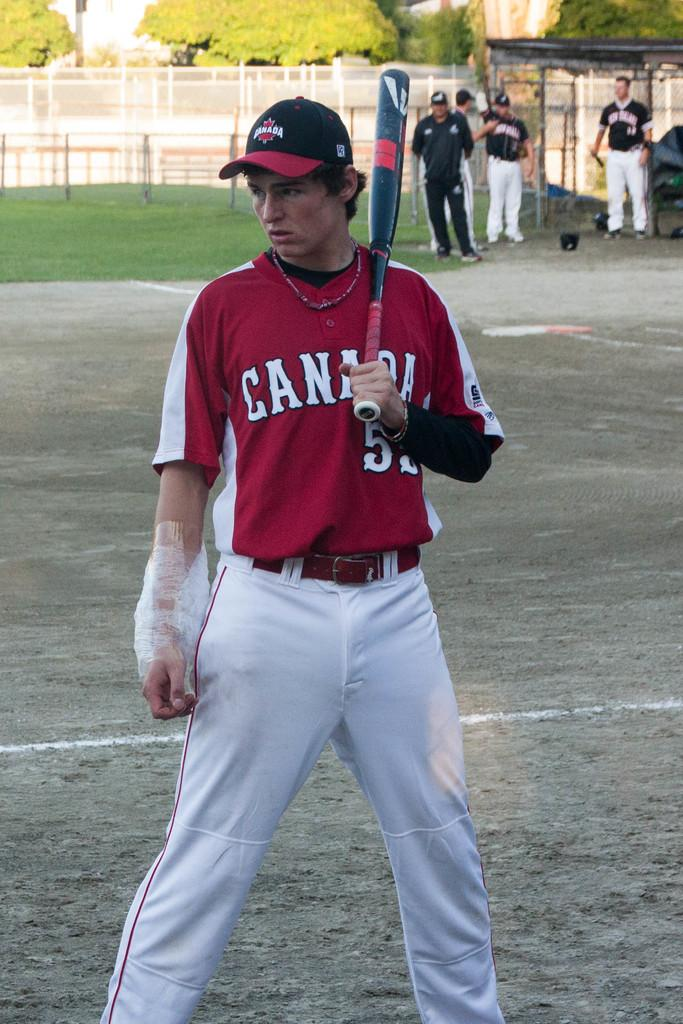<image>
Give a short and clear explanation of the subsequent image. baseball team canada number 5 standing on the field. 